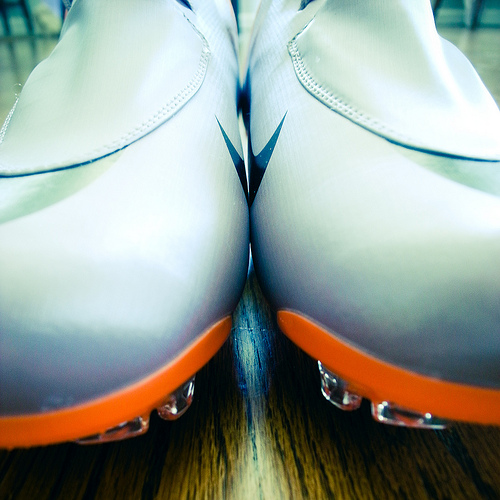<image>
Can you confirm if the shoe is behind the shoe? No. The shoe is not behind the shoe. From this viewpoint, the shoe appears to be positioned elsewhere in the scene. 